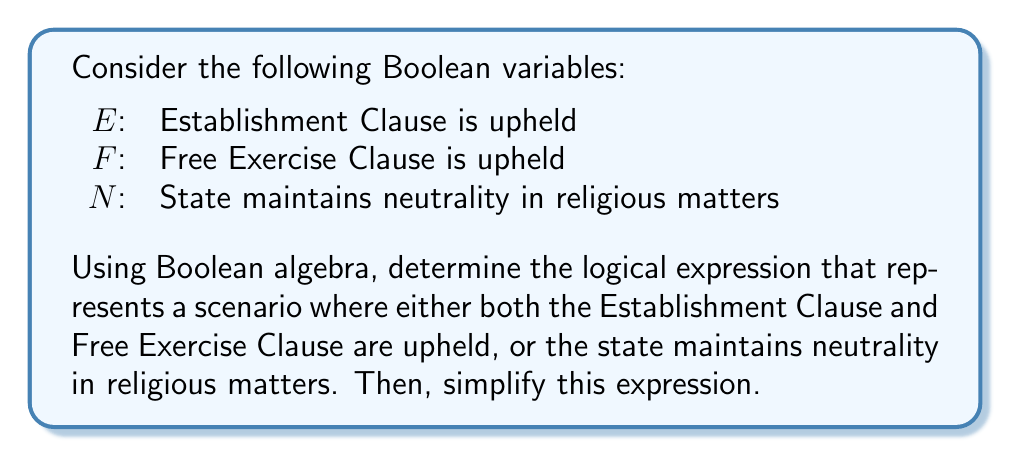Could you help me with this problem? 1. First, let's translate the given scenario into a Boolean expression:
   $(E \land F) \lor N$

2. To simplify this expression, we can use the distributive law of Boolean algebra:
   $(E \land F) \lor N = (E \lor N) \land (F \lor N)$

3. This simplification is based on the following logic:
   - If $N$ is true, the entire expression is true regardless of $E$ and $F$.
   - If $N$ is false, then both $E$ and $F$ must be true for the expression to be true.

4. We can verify this simplification using a truth table:

   | $E$ | $F$ | $N$ | $(E \land F) \lor N$ | $(E \lor N) \land (F \lor N)$ |
   |-----|-----|-----|---------------------|-------------------------------|
   | 0   | 0   | 0   | 0                   | 0                             |
   | 0   | 0   | 1   | 1                   | 1                             |
   | 0   | 1   | 0   | 0                   | 0                             |
   | 0   | 1   | 1   | 1                   | 1                             |
   | 1   | 0   | 0   | 0                   | 0                             |
   | 1   | 0   | 1   | 1                   | 1                             |
   | 1   | 1   | 0   | 1                   | 1                             |
   | 1   | 1   | 1   | 1                   | 1                             |

5. The truth table confirms that the original expression and the simplified expression are logically equivalent.

This simplification demonstrates that the constitutional requirement for religious freedom can be met either by upholding both clauses or by maintaining state neutrality, which aligns with the historical interpretation of the First Amendment.
Answer: $(E \lor N) \land (F \lor N)$ 